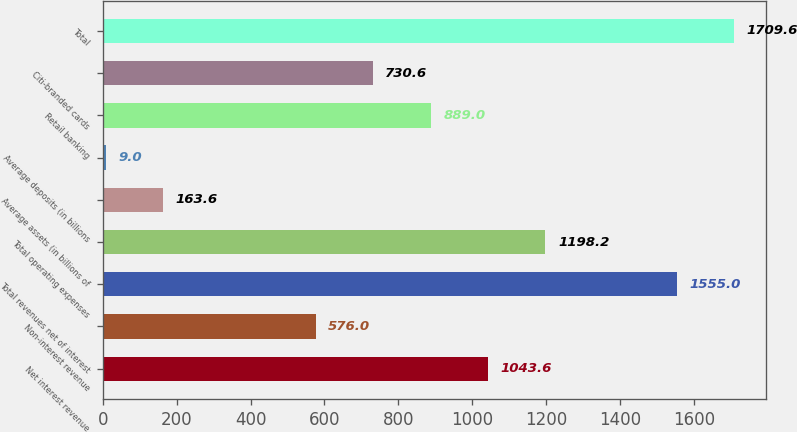<chart> <loc_0><loc_0><loc_500><loc_500><bar_chart><fcel>Net interest revenue<fcel>Non-interest revenue<fcel>Total revenues net of interest<fcel>Total operating expenses<fcel>Average assets (in billions of<fcel>Average deposits (in billions<fcel>Retail banking<fcel>Citi-branded cards<fcel>Total<nl><fcel>1043.6<fcel>576<fcel>1555<fcel>1198.2<fcel>163.6<fcel>9<fcel>889<fcel>730.6<fcel>1709.6<nl></chart> 